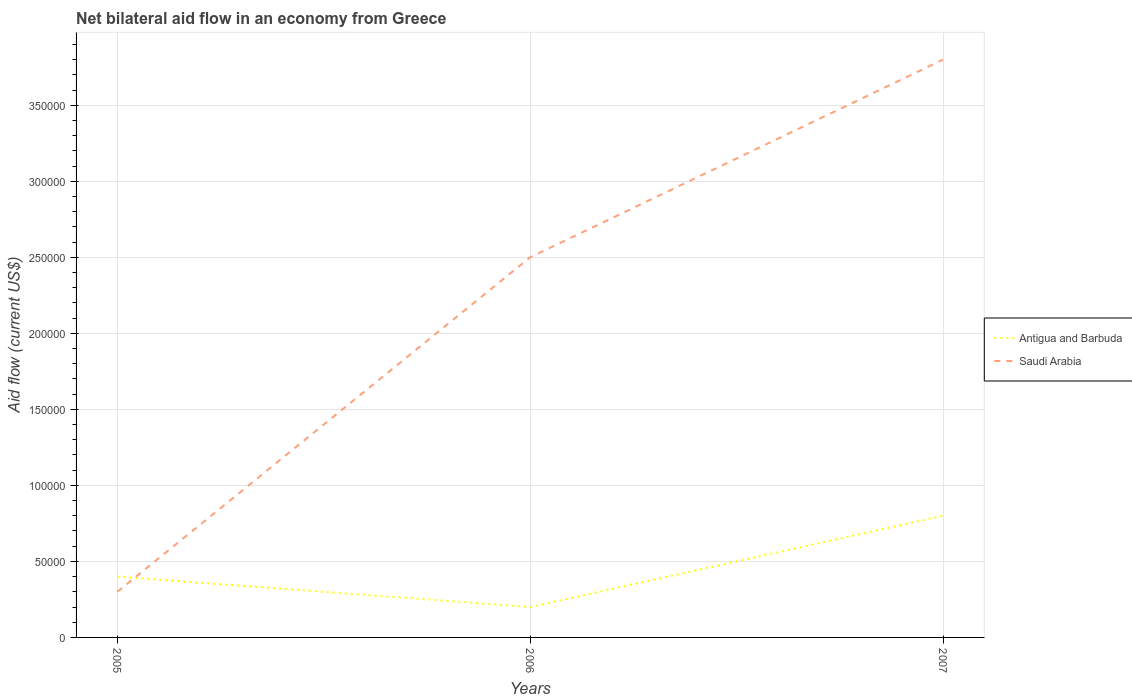How many different coloured lines are there?
Ensure brevity in your answer.  2. Is the number of lines equal to the number of legend labels?
Ensure brevity in your answer.  Yes. What is the total net bilateral aid flow in Antigua and Barbuda in the graph?
Your answer should be very brief. -4.00e+04. What is the difference between the highest and the second highest net bilateral aid flow in Saudi Arabia?
Your response must be concise. 3.50e+05. How many lines are there?
Keep it short and to the point. 2. How many years are there in the graph?
Ensure brevity in your answer.  3. Are the values on the major ticks of Y-axis written in scientific E-notation?
Ensure brevity in your answer.  No. Where does the legend appear in the graph?
Ensure brevity in your answer.  Center right. How many legend labels are there?
Your response must be concise. 2. How are the legend labels stacked?
Give a very brief answer. Vertical. What is the title of the graph?
Provide a short and direct response. Net bilateral aid flow in an economy from Greece. What is the label or title of the Y-axis?
Offer a very short reply. Aid flow (current US$). What is the Aid flow (current US$) of Antigua and Barbuda in 2005?
Offer a terse response. 4.00e+04. Across all years, what is the maximum Aid flow (current US$) of Antigua and Barbuda?
Your response must be concise. 8.00e+04. Across all years, what is the maximum Aid flow (current US$) in Saudi Arabia?
Offer a very short reply. 3.80e+05. Across all years, what is the minimum Aid flow (current US$) in Antigua and Barbuda?
Your answer should be compact. 2.00e+04. What is the total Aid flow (current US$) in Antigua and Barbuda in the graph?
Your answer should be compact. 1.40e+05. What is the total Aid flow (current US$) of Saudi Arabia in the graph?
Ensure brevity in your answer.  6.60e+05. What is the difference between the Aid flow (current US$) of Antigua and Barbuda in 2005 and that in 2006?
Offer a terse response. 2.00e+04. What is the difference between the Aid flow (current US$) of Saudi Arabia in 2005 and that in 2006?
Offer a very short reply. -2.20e+05. What is the difference between the Aid flow (current US$) in Antigua and Barbuda in 2005 and that in 2007?
Give a very brief answer. -4.00e+04. What is the difference between the Aid flow (current US$) of Saudi Arabia in 2005 and that in 2007?
Offer a very short reply. -3.50e+05. What is the difference between the Aid flow (current US$) in Antigua and Barbuda in 2006 and that in 2007?
Your answer should be compact. -6.00e+04. What is the difference between the Aid flow (current US$) of Saudi Arabia in 2006 and that in 2007?
Give a very brief answer. -1.30e+05. What is the difference between the Aid flow (current US$) in Antigua and Barbuda in 2005 and the Aid flow (current US$) in Saudi Arabia in 2006?
Provide a succinct answer. -2.10e+05. What is the difference between the Aid flow (current US$) in Antigua and Barbuda in 2006 and the Aid flow (current US$) in Saudi Arabia in 2007?
Your response must be concise. -3.60e+05. What is the average Aid flow (current US$) of Antigua and Barbuda per year?
Offer a terse response. 4.67e+04. In the year 2005, what is the difference between the Aid flow (current US$) in Antigua and Barbuda and Aid flow (current US$) in Saudi Arabia?
Ensure brevity in your answer.  10000. In the year 2006, what is the difference between the Aid flow (current US$) of Antigua and Barbuda and Aid flow (current US$) of Saudi Arabia?
Ensure brevity in your answer.  -2.30e+05. In the year 2007, what is the difference between the Aid flow (current US$) of Antigua and Barbuda and Aid flow (current US$) of Saudi Arabia?
Your response must be concise. -3.00e+05. What is the ratio of the Aid flow (current US$) of Antigua and Barbuda in 2005 to that in 2006?
Offer a very short reply. 2. What is the ratio of the Aid flow (current US$) in Saudi Arabia in 2005 to that in 2006?
Keep it short and to the point. 0.12. What is the ratio of the Aid flow (current US$) in Saudi Arabia in 2005 to that in 2007?
Provide a succinct answer. 0.08. What is the ratio of the Aid flow (current US$) of Saudi Arabia in 2006 to that in 2007?
Your answer should be compact. 0.66. What is the difference between the highest and the second highest Aid flow (current US$) in Antigua and Barbuda?
Your response must be concise. 4.00e+04. What is the difference between the highest and the second highest Aid flow (current US$) in Saudi Arabia?
Offer a very short reply. 1.30e+05. What is the difference between the highest and the lowest Aid flow (current US$) of Saudi Arabia?
Make the answer very short. 3.50e+05. 